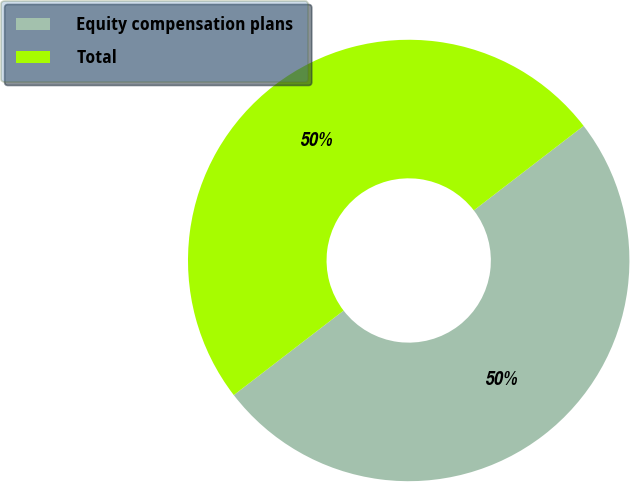<chart> <loc_0><loc_0><loc_500><loc_500><pie_chart><fcel>Equity compensation plans<fcel>Total<nl><fcel>50.0%<fcel>50.0%<nl></chart> 